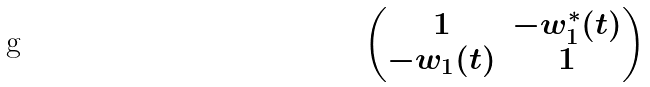<formula> <loc_0><loc_0><loc_500><loc_500>\begin{pmatrix} 1 & - w _ { 1 } ^ { * } ( t ) \\ - w _ { 1 } ( t ) & 1 \end{pmatrix}</formula> 